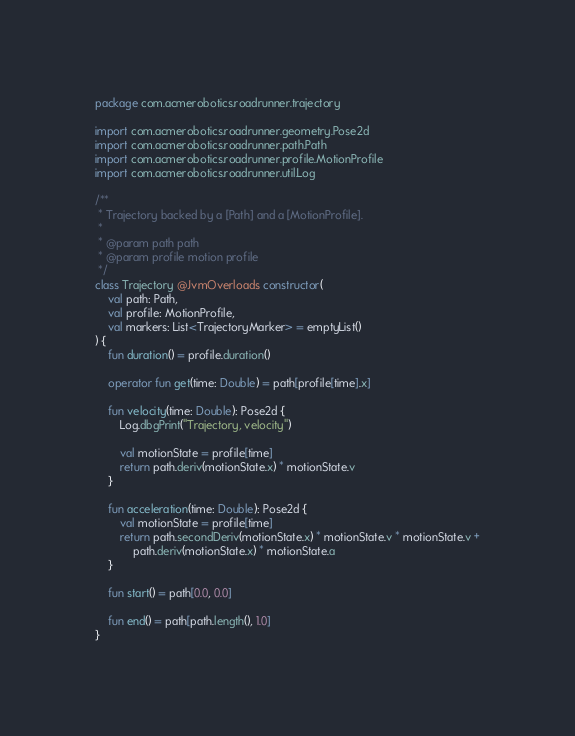<code> <loc_0><loc_0><loc_500><loc_500><_Kotlin_>package com.acmerobotics.roadrunner.trajectory

import com.acmerobotics.roadrunner.geometry.Pose2d
import com.acmerobotics.roadrunner.path.Path
import com.acmerobotics.roadrunner.profile.MotionProfile
import com.acmerobotics.roadrunner.util.Log

/**
 * Trajectory backed by a [Path] and a [MotionProfile].
 *
 * @param path path
 * @param profile motion profile
 */
class Trajectory @JvmOverloads constructor(
    val path: Path,
    val profile: MotionProfile,
    val markers: List<TrajectoryMarker> = emptyList()
) {
    fun duration() = profile.duration()

    operator fun get(time: Double) = path[profile[time].x]

    fun velocity(time: Double): Pose2d {
        Log.dbgPrint("Trajectory, velocity")

        val motionState = profile[time]
        return path.deriv(motionState.x) * motionState.v
    }

    fun acceleration(time: Double): Pose2d {
        val motionState = profile[time]
        return path.secondDeriv(motionState.x) * motionState.v * motionState.v +
            path.deriv(motionState.x) * motionState.a
    }

    fun start() = path[0.0, 0.0]

    fun end() = path[path.length(), 1.0]
}
</code> 